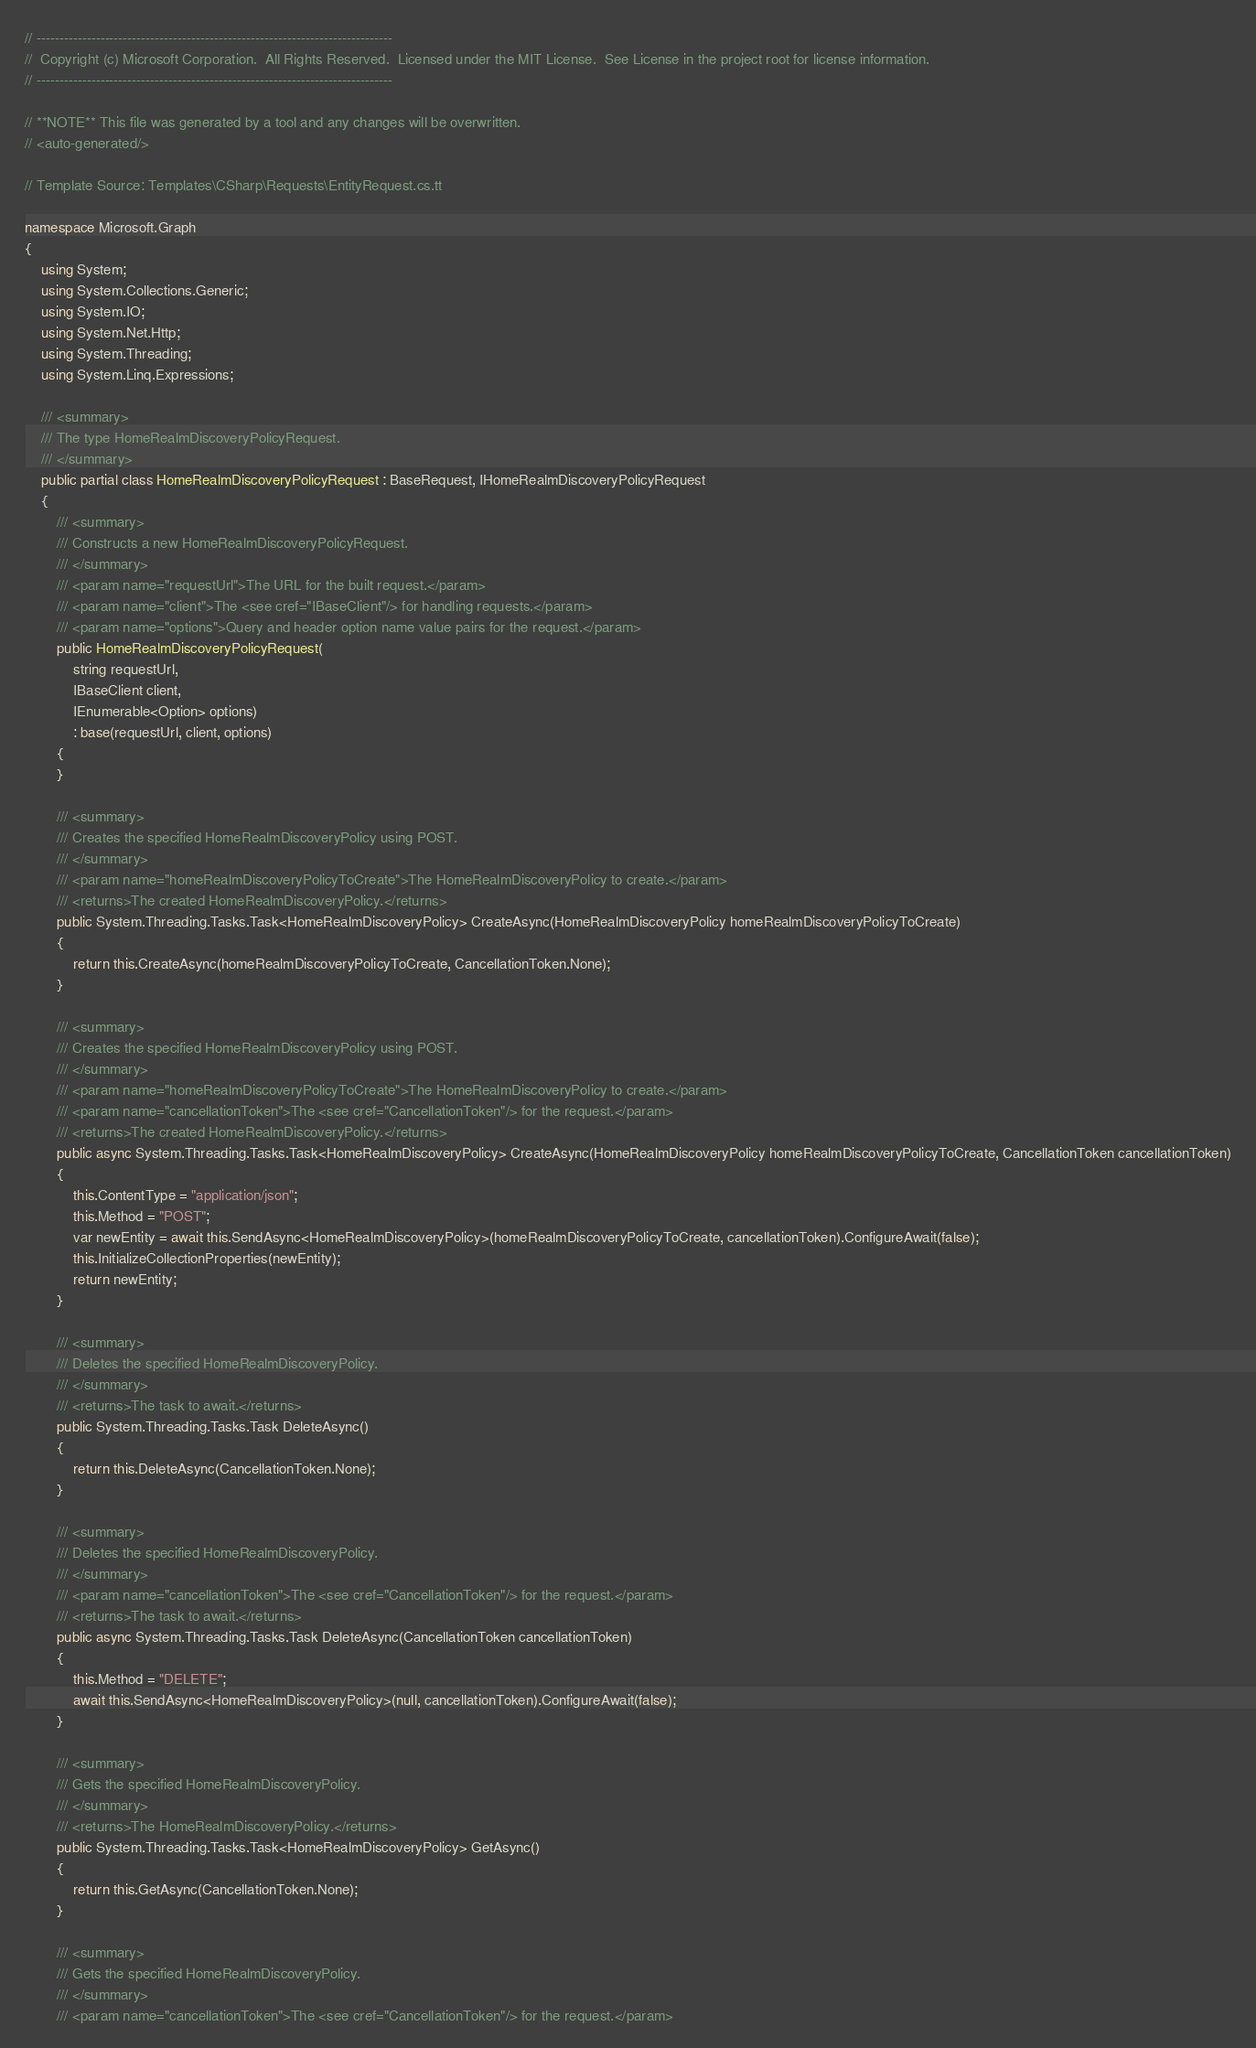<code> <loc_0><loc_0><loc_500><loc_500><_C#_>// ------------------------------------------------------------------------------
//  Copyright (c) Microsoft Corporation.  All Rights Reserved.  Licensed under the MIT License.  See License in the project root for license information.
// ------------------------------------------------------------------------------

// **NOTE** This file was generated by a tool and any changes will be overwritten.
// <auto-generated/>

// Template Source: Templates\CSharp\Requests\EntityRequest.cs.tt

namespace Microsoft.Graph
{
    using System;
    using System.Collections.Generic;
    using System.IO;
    using System.Net.Http;
    using System.Threading;
    using System.Linq.Expressions;

    /// <summary>
    /// The type HomeRealmDiscoveryPolicyRequest.
    /// </summary>
    public partial class HomeRealmDiscoveryPolicyRequest : BaseRequest, IHomeRealmDiscoveryPolicyRequest
    {
        /// <summary>
        /// Constructs a new HomeRealmDiscoveryPolicyRequest.
        /// </summary>
        /// <param name="requestUrl">The URL for the built request.</param>
        /// <param name="client">The <see cref="IBaseClient"/> for handling requests.</param>
        /// <param name="options">Query and header option name value pairs for the request.</param>
        public HomeRealmDiscoveryPolicyRequest(
            string requestUrl,
            IBaseClient client,
            IEnumerable<Option> options)
            : base(requestUrl, client, options)
        {
        }

        /// <summary>
        /// Creates the specified HomeRealmDiscoveryPolicy using POST.
        /// </summary>
        /// <param name="homeRealmDiscoveryPolicyToCreate">The HomeRealmDiscoveryPolicy to create.</param>
        /// <returns>The created HomeRealmDiscoveryPolicy.</returns>
        public System.Threading.Tasks.Task<HomeRealmDiscoveryPolicy> CreateAsync(HomeRealmDiscoveryPolicy homeRealmDiscoveryPolicyToCreate)
        {
            return this.CreateAsync(homeRealmDiscoveryPolicyToCreate, CancellationToken.None);
        }

        /// <summary>
        /// Creates the specified HomeRealmDiscoveryPolicy using POST.
        /// </summary>
        /// <param name="homeRealmDiscoveryPolicyToCreate">The HomeRealmDiscoveryPolicy to create.</param>
        /// <param name="cancellationToken">The <see cref="CancellationToken"/> for the request.</param>
        /// <returns>The created HomeRealmDiscoveryPolicy.</returns>
        public async System.Threading.Tasks.Task<HomeRealmDiscoveryPolicy> CreateAsync(HomeRealmDiscoveryPolicy homeRealmDiscoveryPolicyToCreate, CancellationToken cancellationToken)
        {
            this.ContentType = "application/json";
            this.Method = "POST";
            var newEntity = await this.SendAsync<HomeRealmDiscoveryPolicy>(homeRealmDiscoveryPolicyToCreate, cancellationToken).ConfigureAwait(false);
            this.InitializeCollectionProperties(newEntity);
            return newEntity;
        }

        /// <summary>
        /// Deletes the specified HomeRealmDiscoveryPolicy.
        /// </summary>
        /// <returns>The task to await.</returns>
        public System.Threading.Tasks.Task DeleteAsync()
        {
            return this.DeleteAsync(CancellationToken.None);
        }

        /// <summary>
        /// Deletes the specified HomeRealmDiscoveryPolicy.
        /// </summary>
        /// <param name="cancellationToken">The <see cref="CancellationToken"/> for the request.</param>
        /// <returns>The task to await.</returns>
        public async System.Threading.Tasks.Task DeleteAsync(CancellationToken cancellationToken)
        {
            this.Method = "DELETE";
            await this.SendAsync<HomeRealmDiscoveryPolicy>(null, cancellationToken).ConfigureAwait(false);
        }

        /// <summary>
        /// Gets the specified HomeRealmDiscoveryPolicy.
        /// </summary>
        /// <returns>The HomeRealmDiscoveryPolicy.</returns>
        public System.Threading.Tasks.Task<HomeRealmDiscoveryPolicy> GetAsync()
        {
            return this.GetAsync(CancellationToken.None);
        }

        /// <summary>
        /// Gets the specified HomeRealmDiscoveryPolicy.
        /// </summary>
        /// <param name="cancellationToken">The <see cref="CancellationToken"/> for the request.</param></code> 